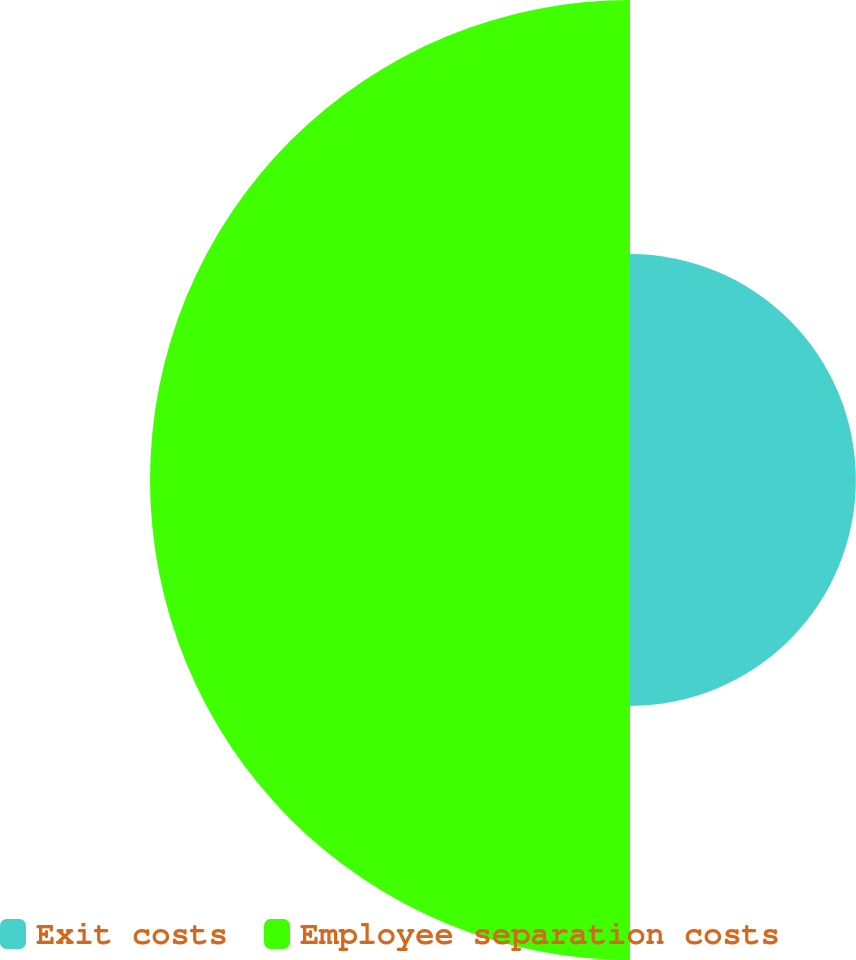<chart> <loc_0><loc_0><loc_500><loc_500><pie_chart><fcel>Exit costs<fcel>Employee separation costs<nl><fcel>32.0%<fcel>68.0%<nl></chart> 